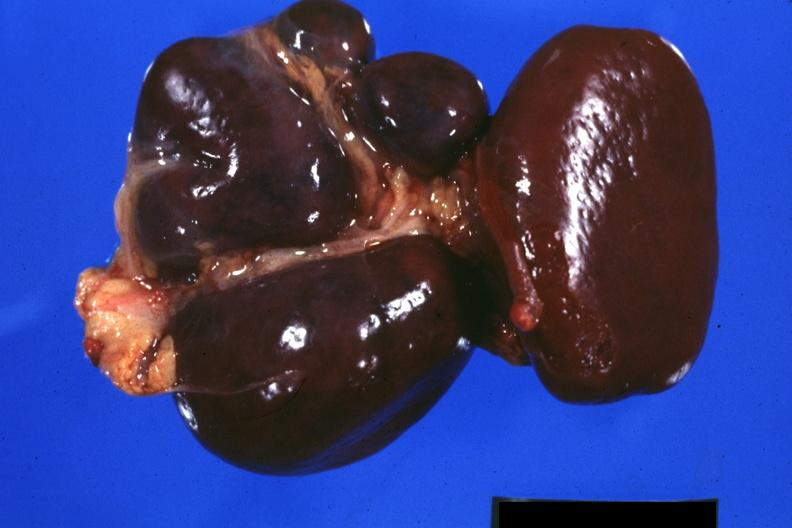s digital infarcts bacterial endocarditis present?
Answer the question using a single word or phrase. No 